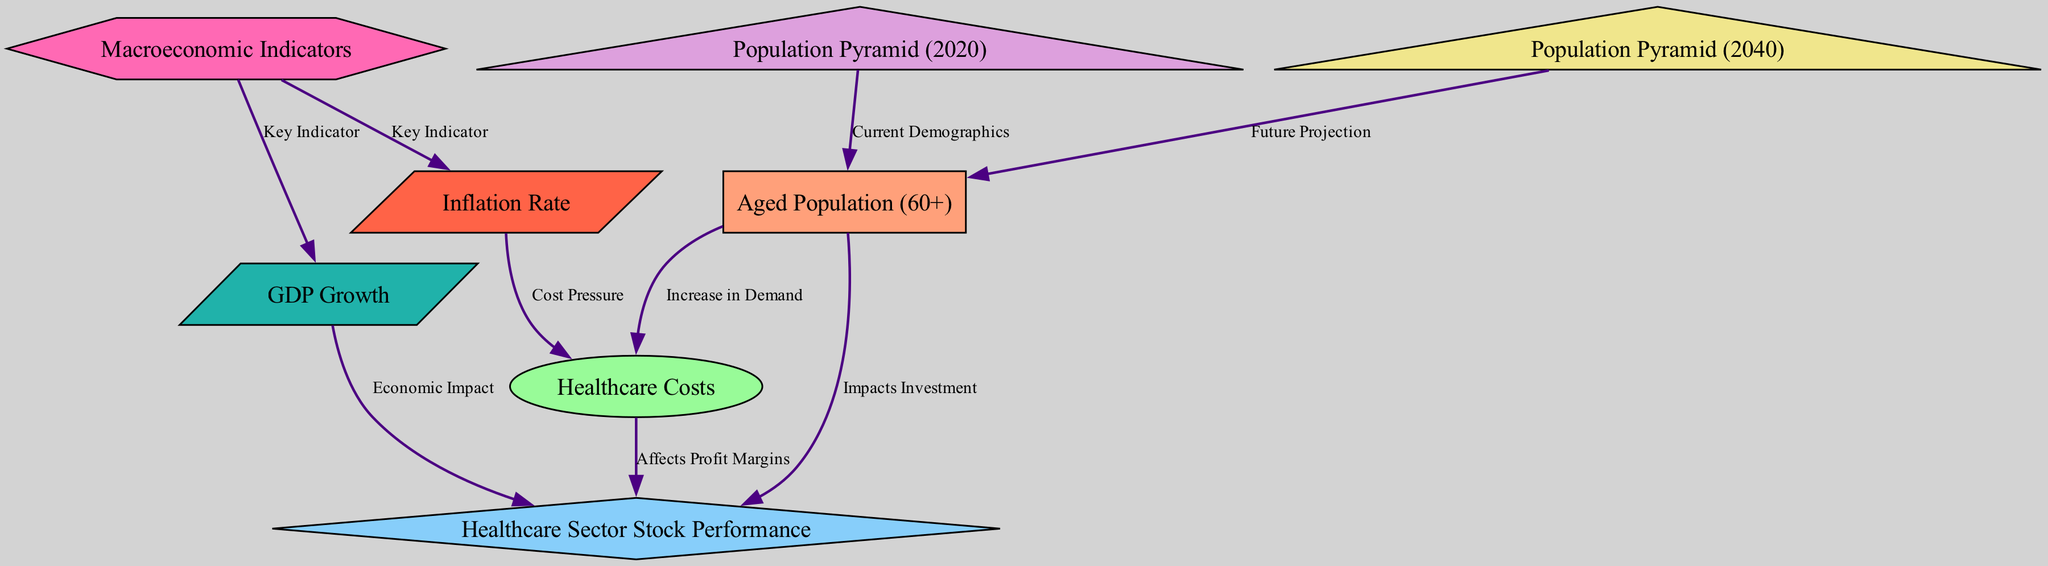What is the relationship between the aged population (60+) and healthcare costs? The diagram shows that an increase in the aged population (60+) leads to an increase in demand for healthcare services, which in turn results in higher healthcare costs.
Answer: Increase in Demand How many population pyramids are represented in the diagram? There are two population pyramids depicted in the diagram: one for the year 2020 and another for the year 2040.
Answer: 2 What does the inflation rate indicate about healthcare costs? The diagram indicates that the inflation rate exerts cost pressure on healthcare costs, implying that as inflation increases, healthcare costs are likely to rise.
Answer: Cost Pressure What is the impact of GDP growth on healthcare sector stock performance? The diagram shows that GDP growth affects healthcare sector stock performance by presenting an economic impact, meaning that higher GDP growth can lead to improved stock performance in the healthcare sector.
Answer: Economic Impact Which two indicators are connected to macroeconomic indicators? The macroeconomic indicators connect to GDP growth and the inflation rate as key indicators, both of which influence the broader economic context.
Answer: GDP growth and Inflation rate What do the population pyramids for 2020 and 2040 represent in the context of aged demographics? The population pyramids illustrate the current demographics for 2020 and project future demographics for 2040, showing changes in the aged population (60+) over time.
Answer: Current Demographics and Future Projection How does the aged population (60+) impact healthcare sector stock performance? The diagram illustrates that the aged population (60+) impacts investment, meaning that a growing aged population can attract more investment in the healthcare sector, influencing stock performance positively.
Answer: Impacts Investment What type of graph structure is used to visualize the data in the diagram? The diagram is structured as a directed graph, showcasing nodes representing different elements and edges displaying their relationships.
Answer: Directed Graph 